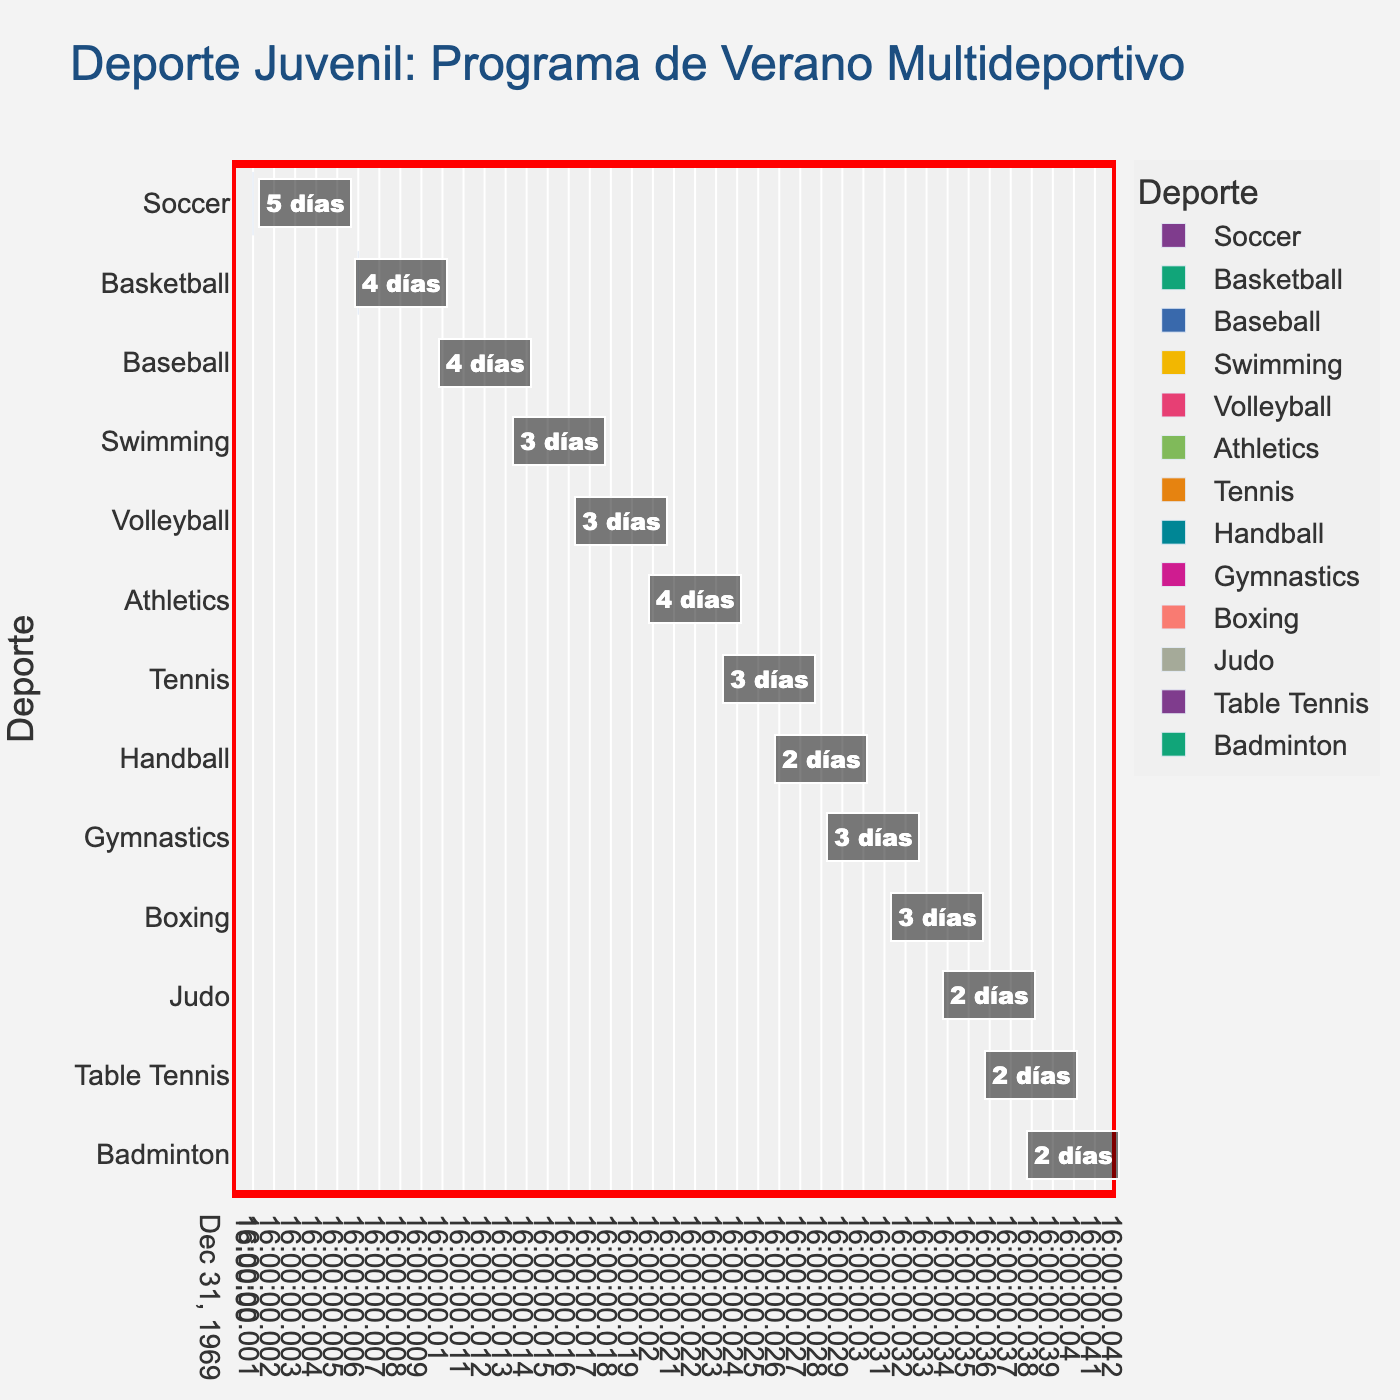What is the title of the Gantt chart? The title is located at the top center of the Gantt chart. It is in larger font than other text elements and provides an overview of what the chart represents.
Answer: Deporte Juvenil: Programa de Verano Multideportivo How many total sports are scheduled in the summer camp? Each sport is listed along the y-axis of the Gantt chart. Counting them provides the total number.
Answer: 13 Which sport has the longest duration in the schedule? By examining the horizontal bars, the sport with the longest bar length from start to end has the longest duration.
Answer: Soccer On which day does Basketball start? The start day for each sport is marked at the left end of the corresponding bar.
Answer: Day 6 What is the total duration of all sports combined? Sum up the durations of each sport: 5 (Soccer) + 4 (Basketball) + 4 (Baseball) + 3 (Swimming) + 3 (Volleyball) + 4 (Athletics) + 3 (Tennis) + 2 (Handball) + 3 (Gymnastics) + 3 (Boxing) + 2 (Judo) + 2 (Table Tennis) + 2 (Badminton) = 40
Answer: 40 days Which sports start after Day 20? Identify sports whose bars start on or after Day 20 by looking at the x-axis labels and positions of the bars.
Answer: Tennis, Handball, Gymnastics, Boxing, Judo, Table Tennis, Badminton Which sport occupies the last scheduled slot? The sport with the bar reaching furthest to the right on the timeline.
Answer: Badminton How many sports have a duration of 3 days? Count the number of bars labeled with “3 días” in the annotations.
Answer: 5 What is the difference in duration between Baseball and Handball? Subtract the duration of Handball from the duration of Baseball: 4 (Baseball) - 2 (Handball) = 2
Answer: 2 days If Athletics were to start immediately after Basketball, on which day would it end? Athletics starts on Day 20 and lasts 4 days, thus ending on Day 24. If it started immediately after Basketball (which ends on Day 9 + 4 days = Day 10), it would end on Day 10 + 4 days = Day 14.
Answer: Day 14 